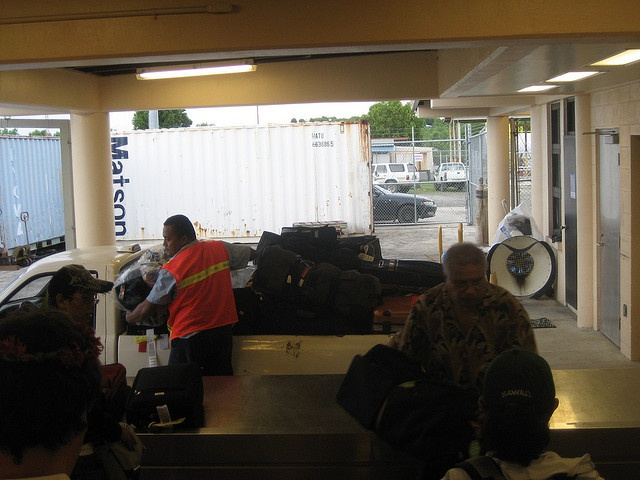Describe the objects in this image and their specific colors. I can see truck in maroon, white, darkgray, gray, and tan tones, people in black and maroon tones, truck in maroon, olive, black, gray, and darkgray tones, people in maroon, black, and gray tones, and people in maroon, black, brown, and gray tones in this image. 